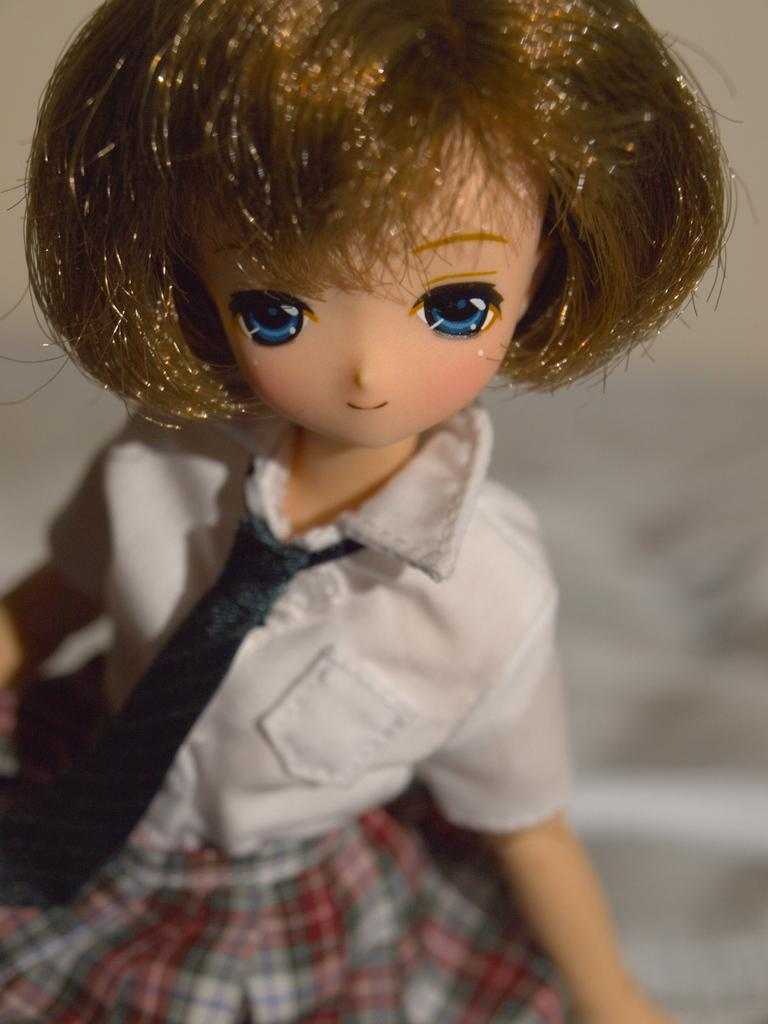What is located in the foreground of the image? There is a toy in the foreground of the image. How does the toy show respect to the mailbox in the image? There is no mailbox present in the image, so the toy cannot show respect to a mailbox. 